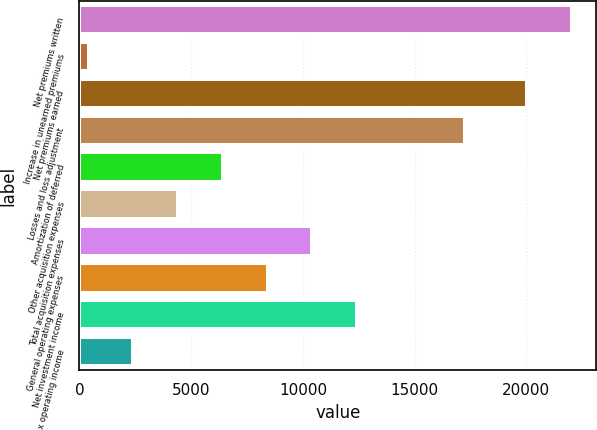Convert chart to OTSL. <chart><loc_0><loc_0><loc_500><loc_500><bar_chart><fcel>Net premiums written<fcel>Increase in unearned premiums<fcel>Net premiums earned<fcel>Losses and loss adjustment<fcel>Amortization of deferred<fcel>Other acquisition expenses<fcel>Total acquisition expenses<fcel>General operating expenses<fcel>Net investment income<fcel>Pre-tax operating income<nl><fcel>22031.9<fcel>407<fcel>20029<fcel>17274<fcel>6415.7<fcel>4412.8<fcel>10421.5<fcel>8418.6<fcel>12424.4<fcel>2409.9<nl></chart> 